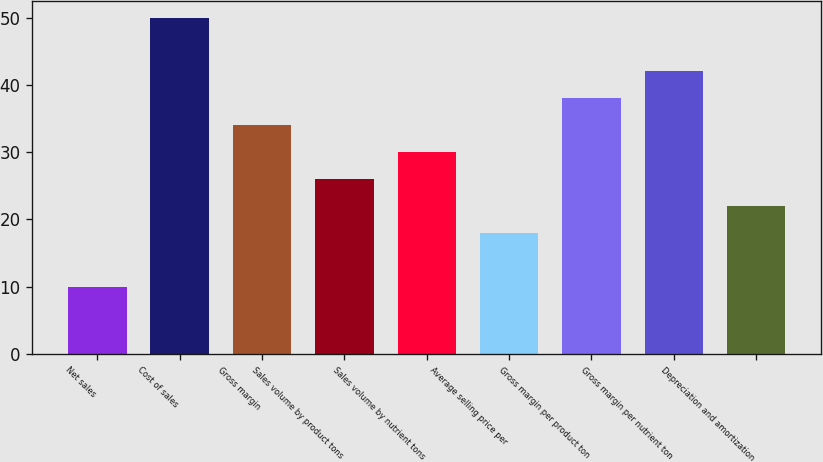Convert chart. <chart><loc_0><loc_0><loc_500><loc_500><bar_chart><fcel>Net sales<fcel>Cost of sales<fcel>Gross margin<fcel>Sales volume by product tons<fcel>Sales volume by nutrient tons<fcel>Average selling price per<fcel>Gross margin per product ton<fcel>Gross margin per nutrient ton<fcel>Depreciation and amortization<nl><fcel>10<fcel>50<fcel>34<fcel>26<fcel>30<fcel>18<fcel>38<fcel>42<fcel>22<nl></chart> 